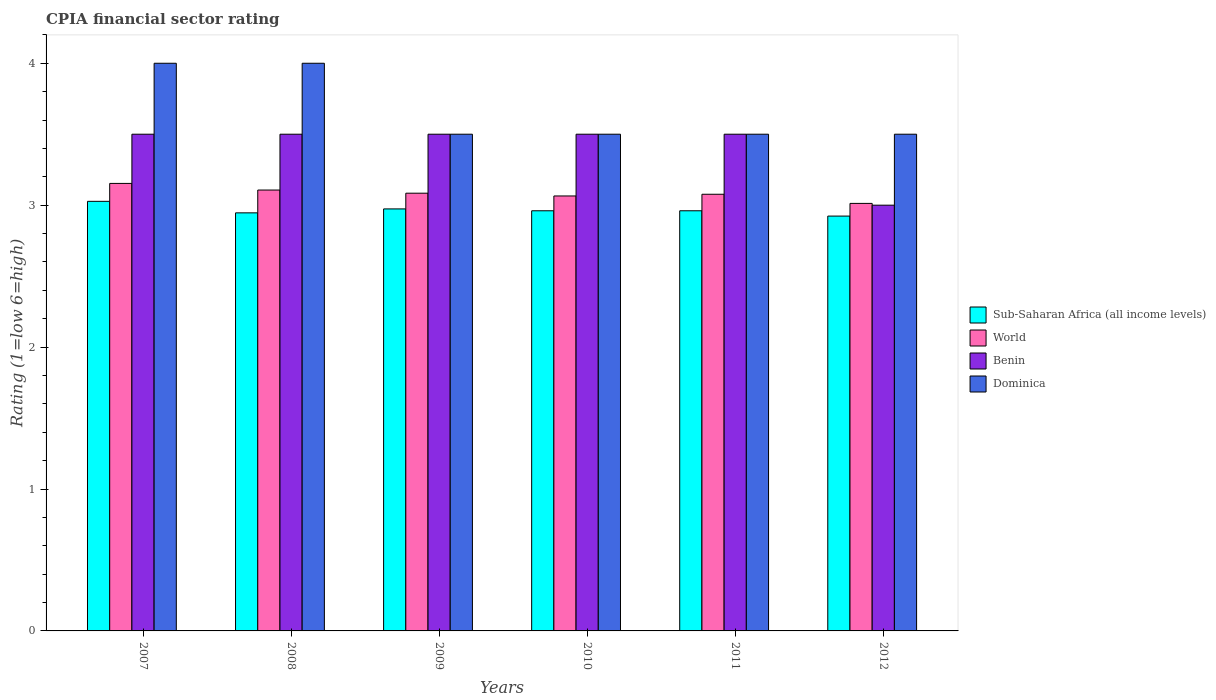How many groups of bars are there?
Make the answer very short. 6. How many bars are there on the 2nd tick from the left?
Offer a terse response. 4. In how many cases, is the number of bars for a given year not equal to the number of legend labels?
Your answer should be compact. 0. What is the CPIA rating in Dominica in 2010?
Give a very brief answer. 3.5. Across all years, what is the maximum CPIA rating in World?
Your response must be concise. 3.15. Across all years, what is the minimum CPIA rating in World?
Offer a very short reply. 3.01. What is the total CPIA rating in World in the graph?
Your answer should be compact. 18.5. What is the difference between the CPIA rating in Benin in 2009 and that in 2010?
Your answer should be compact. 0. What is the difference between the CPIA rating in Benin in 2010 and the CPIA rating in Sub-Saharan Africa (all income levels) in 2012?
Offer a very short reply. 0.58. What is the average CPIA rating in Sub-Saharan Africa (all income levels) per year?
Keep it short and to the point. 2.97. In the year 2011, what is the difference between the CPIA rating in Sub-Saharan Africa (all income levels) and CPIA rating in Dominica?
Ensure brevity in your answer.  -0.54. What is the ratio of the CPIA rating in Sub-Saharan Africa (all income levels) in 2009 to that in 2011?
Your response must be concise. 1. Is the difference between the CPIA rating in Sub-Saharan Africa (all income levels) in 2011 and 2012 greater than the difference between the CPIA rating in Dominica in 2011 and 2012?
Your answer should be compact. Yes. What is the difference between the highest and the second highest CPIA rating in World?
Your answer should be very brief. 0.05. What is the difference between the highest and the lowest CPIA rating in World?
Your response must be concise. 0.14. Is the sum of the CPIA rating in World in 2010 and 2012 greater than the maximum CPIA rating in Dominica across all years?
Offer a very short reply. Yes. Is it the case that in every year, the sum of the CPIA rating in Benin and CPIA rating in Sub-Saharan Africa (all income levels) is greater than the sum of CPIA rating in World and CPIA rating in Dominica?
Give a very brief answer. No. What does the 1st bar from the left in 2007 represents?
Your answer should be compact. Sub-Saharan Africa (all income levels). What does the 1st bar from the right in 2007 represents?
Offer a very short reply. Dominica. How many bars are there?
Your answer should be compact. 24. Are all the bars in the graph horizontal?
Give a very brief answer. No. How many years are there in the graph?
Provide a short and direct response. 6. Are the values on the major ticks of Y-axis written in scientific E-notation?
Offer a terse response. No. How are the legend labels stacked?
Your response must be concise. Vertical. What is the title of the graph?
Your answer should be compact. CPIA financial sector rating. Does "High income: OECD" appear as one of the legend labels in the graph?
Offer a very short reply. No. What is the label or title of the Y-axis?
Provide a short and direct response. Rating (1=low 6=high). What is the Rating (1=low 6=high) of Sub-Saharan Africa (all income levels) in 2007?
Your answer should be compact. 3.03. What is the Rating (1=low 6=high) in World in 2007?
Offer a very short reply. 3.15. What is the Rating (1=low 6=high) of Dominica in 2007?
Your answer should be compact. 4. What is the Rating (1=low 6=high) in Sub-Saharan Africa (all income levels) in 2008?
Provide a short and direct response. 2.95. What is the Rating (1=low 6=high) of World in 2008?
Give a very brief answer. 3.11. What is the Rating (1=low 6=high) in Benin in 2008?
Keep it short and to the point. 3.5. What is the Rating (1=low 6=high) of Dominica in 2008?
Your answer should be compact. 4. What is the Rating (1=low 6=high) in Sub-Saharan Africa (all income levels) in 2009?
Keep it short and to the point. 2.97. What is the Rating (1=low 6=high) in World in 2009?
Provide a succinct answer. 3.08. What is the Rating (1=low 6=high) of Sub-Saharan Africa (all income levels) in 2010?
Your answer should be compact. 2.96. What is the Rating (1=low 6=high) of World in 2010?
Offer a very short reply. 3.06. What is the Rating (1=low 6=high) in Sub-Saharan Africa (all income levels) in 2011?
Offer a very short reply. 2.96. What is the Rating (1=low 6=high) of World in 2011?
Your response must be concise. 3.08. What is the Rating (1=low 6=high) of Benin in 2011?
Keep it short and to the point. 3.5. What is the Rating (1=low 6=high) in Sub-Saharan Africa (all income levels) in 2012?
Offer a very short reply. 2.92. What is the Rating (1=low 6=high) in World in 2012?
Offer a very short reply. 3.01. Across all years, what is the maximum Rating (1=low 6=high) in Sub-Saharan Africa (all income levels)?
Make the answer very short. 3.03. Across all years, what is the maximum Rating (1=low 6=high) in World?
Make the answer very short. 3.15. Across all years, what is the maximum Rating (1=low 6=high) of Dominica?
Make the answer very short. 4. Across all years, what is the minimum Rating (1=low 6=high) of Sub-Saharan Africa (all income levels)?
Offer a terse response. 2.92. Across all years, what is the minimum Rating (1=low 6=high) in World?
Your answer should be very brief. 3.01. Across all years, what is the minimum Rating (1=low 6=high) of Benin?
Ensure brevity in your answer.  3. Across all years, what is the minimum Rating (1=low 6=high) of Dominica?
Keep it short and to the point. 3.5. What is the total Rating (1=low 6=high) in Sub-Saharan Africa (all income levels) in the graph?
Ensure brevity in your answer.  17.79. What is the total Rating (1=low 6=high) in World in the graph?
Offer a very short reply. 18.5. What is the difference between the Rating (1=low 6=high) in Sub-Saharan Africa (all income levels) in 2007 and that in 2008?
Ensure brevity in your answer.  0.08. What is the difference between the Rating (1=low 6=high) in World in 2007 and that in 2008?
Ensure brevity in your answer.  0.05. What is the difference between the Rating (1=low 6=high) in Benin in 2007 and that in 2008?
Ensure brevity in your answer.  0. What is the difference between the Rating (1=low 6=high) of Dominica in 2007 and that in 2008?
Make the answer very short. 0. What is the difference between the Rating (1=low 6=high) of Sub-Saharan Africa (all income levels) in 2007 and that in 2009?
Make the answer very short. 0.05. What is the difference between the Rating (1=low 6=high) of World in 2007 and that in 2009?
Your answer should be very brief. 0.07. What is the difference between the Rating (1=low 6=high) in Benin in 2007 and that in 2009?
Keep it short and to the point. 0. What is the difference between the Rating (1=low 6=high) in Dominica in 2007 and that in 2009?
Keep it short and to the point. 0.5. What is the difference between the Rating (1=low 6=high) in Sub-Saharan Africa (all income levels) in 2007 and that in 2010?
Make the answer very short. 0.07. What is the difference between the Rating (1=low 6=high) in World in 2007 and that in 2010?
Give a very brief answer. 0.09. What is the difference between the Rating (1=low 6=high) of Benin in 2007 and that in 2010?
Offer a terse response. 0. What is the difference between the Rating (1=low 6=high) of Dominica in 2007 and that in 2010?
Ensure brevity in your answer.  0.5. What is the difference between the Rating (1=low 6=high) of Sub-Saharan Africa (all income levels) in 2007 and that in 2011?
Give a very brief answer. 0.07. What is the difference between the Rating (1=low 6=high) of World in 2007 and that in 2011?
Provide a succinct answer. 0.08. What is the difference between the Rating (1=low 6=high) of Dominica in 2007 and that in 2011?
Offer a terse response. 0.5. What is the difference between the Rating (1=low 6=high) of Sub-Saharan Africa (all income levels) in 2007 and that in 2012?
Your answer should be very brief. 0.1. What is the difference between the Rating (1=low 6=high) of World in 2007 and that in 2012?
Ensure brevity in your answer.  0.14. What is the difference between the Rating (1=low 6=high) of Dominica in 2007 and that in 2012?
Your answer should be very brief. 0.5. What is the difference between the Rating (1=low 6=high) in Sub-Saharan Africa (all income levels) in 2008 and that in 2009?
Your answer should be compact. -0.03. What is the difference between the Rating (1=low 6=high) in World in 2008 and that in 2009?
Keep it short and to the point. 0.02. What is the difference between the Rating (1=low 6=high) in Benin in 2008 and that in 2009?
Your answer should be very brief. 0. What is the difference between the Rating (1=low 6=high) of Dominica in 2008 and that in 2009?
Ensure brevity in your answer.  0.5. What is the difference between the Rating (1=low 6=high) in Sub-Saharan Africa (all income levels) in 2008 and that in 2010?
Provide a succinct answer. -0.01. What is the difference between the Rating (1=low 6=high) of World in 2008 and that in 2010?
Give a very brief answer. 0.04. What is the difference between the Rating (1=low 6=high) of Sub-Saharan Africa (all income levels) in 2008 and that in 2011?
Give a very brief answer. -0.01. What is the difference between the Rating (1=low 6=high) of World in 2008 and that in 2011?
Provide a succinct answer. 0.03. What is the difference between the Rating (1=low 6=high) of Benin in 2008 and that in 2011?
Provide a succinct answer. 0. What is the difference between the Rating (1=low 6=high) in Dominica in 2008 and that in 2011?
Give a very brief answer. 0.5. What is the difference between the Rating (1=low 6=high) in Sub-Saharan Africa (all income levels) in 2008 and that in 2012?
Ensure brevity in your answer.  0.02. What is the difference between the Rating (1=low 6=high) of World in 2008 and that in 2012?
Keep it short and to the point. 0.09. What is the difference between the Rating (1=low 6=high) in Dominica in 2008 and that in 2012?
Offer a very short reply. 0.5. What is the difference between the Rating (1=low 6=high) of Sub-Saharan Africa (all income levels) in 2009 and that in 2010?
Offer a very short reply. 0.01. What is the difference between the Rating (1=low 6=high) in World in 2009 and that in 2010?
Provide a short and direct response. 0.02. What is the difference between the Rating (1=low 6=high) of Sub-Saharan Africa (all income levels) in 2009 and that in 2011?
Give a very brief answer. 0.01. What is the difference between the Rating (1=low 6=high) in World in 2009 and that in 2011?
Offer a terse response. 0.01. What is the difference between the Rating (1=low 6=high) of Benin in 2009 and that in 2011?
Your answer should be compact. 0. What is the difference between the Rating (1=low 6=high) in Sub-Saharan Africa (all income levels) in 2009 and that in 2012?
Your answer should be very brief. 0.05. What is the difference between the Rating (1=low 6=high) in World in 2009 and that in 2012?
Your response must be concise. 0.07. What is the difference between the Rating (1=low 6=high) of Dominica in 2009 and that in 2012?
Ensure brevity in your answer.  0. What is the difference between the Rating (1=low 6=high) of Sub-Saharan Africa (all income levels) in 2010 and that in 2011?
Keep it short and to the point. 0. What is the difference between the Rating (1=low 6=high) of World in 2010 and that in 2011?
Your response must be concise. -0.01. What is the difference between the Rating (1=low 6=high) in Benin in 2010 and that in 2011?
Offer a very short reply. 0. What is the difference between the Rating (1=low 6=high) of Sub-Saharan Africa (all income levels) in 2010 and that in 2012?
Your response must be concise. 0.04. What is the difference between the Rating (1=low 6=high) of World in 2010 and that in 2012?
Offer a terse response. 0.05. What is the difference between the Rating (1=low 6=high) in Sub-Saharan Africa (all income levels) in 2011 and that in 2012?
Keep it short and to the point. 0.04. What is the difference between the Rating (1=low 6=high) of World in 2011 and that in 2012?
Provide a short and direct response. 0.06. What is the difference between the Rating (1=low 6=high) of Benin in 2011 and that in 2012?
Provide a short and direct response. 0.5. What is the difference between the Rating (1=low 6=high) of Dominica in 2011 and that in 2012?
Give a very brief answer. 0. What is the difference between the Rating (1=low 6=high) of Sub-Saharan Africa (all income levels) in 2007 and the Rating (1=low 6=high) of World in 2008?
Your response must be concise. -0.08. What is the difference between the Rating (1=low 6=high) in Sub-Saharan Africa (all income levels) in 2007 and the Rating (1=low 6=high) in Benin in 2008?
Make the answer very short. -0.47. What is the difference between the Rating (1=low 6=high) of Sub-Saharan Africa (all income levels) in 2007 and the Rating (1=low 6=high) of Dominica in 2008?
Provide a succinct answer. -0.97. What is the difference between the Rating (1=low 6=high) in World in 2007 and the Rating (1=low 6=high) in Benin in 2008?
Make the answer very short. -0.35. What is the difference between the Rating (1=low 6=high) in World in 2007 and the Rating (1=low 6=high) in Dominica in 2008?
Keep it short and to the point. -0.85. What is the difference between the Rating (1=low 6=high) of Sub-Saharan Africa (all income levels) in 2007 and the Rating (1=low 6=high) of World in 2009?
Your response must be concise. -0.06. What is the difference between the Rating (1=low 6=high) in Sub-Saharan Africa (all income levels) in 2007 and the Rating (1=low 6=high) in Benin in 2009?
Your answer should be compact. -0.47. What is the difference between the Rating (1=low 6=high) in Sub-Saharan Africa (all income levels) in 2007 and the Rating (1=low 6=high) in Dominica in 2009?
Offer a very short reply. -0.47. What is the difference between the Rating (1=low 6=high) of World in 2007 and the Rating (1=low 6=high) of Benin in 2009?
Make the answer very short. -0.35. What is the difference between the Rating (1=low 6=high) of World in 2007 and the Rating (1=low 6=high) of Dominica in 2009?
Your response must be concise. -0.35. What is the difference between the Rating (1=low 6=high) in Sub-Saharan Africa (all income levels) in 2007 and the Rating (1=low 6=high) in World in 2010?
Provide a short and direct response. -0.04. What is the difference between the Rating (1=low 6=high) of Sub-Saharan Africa (all income levels) in 2007 and the Rating (1=low 6=high) of Benin in 2010?
Offer a terse response. -0.47. What is the difference between the Rating (1=low 6=high) of Sub-Saharan Africa (all income levels) in 2007 and the Rating (1=low 6=high) of Dominica in 2010?
Offer a very short reply. -0.47. What is the difference between the Rating (1=low 6=high) in World in 2007 and the Rating (1=low 6=high) in Benin in 2010?
Provide a succinct answer. -0.35. What is the difference between the Rating (1=low 6=high) of World in 2007 and the Rating (1=low 6=high) of Dominica in 2010?
Offer a very short reply. -0.35. What is the difference between the Rating (1=low 6=high) of Sub-Saharan Africa (all income levels) in 2007 and the Rating (1=low 6=high) of World in 2011?
Offer a terse response. -0.05. What is the difference between the Rating (1=low 6=high) of Sub-Saharan Africa (all income levels) in 2007 and the Rating (1=low 6=high) of Benin in 2011?
Give a very brief answer. -0.47. What is the difference between the Rating (1=low 6=high) in Sub-Saharan Africa (all income levels) in 2007 and the Rating (1=low 6=high) in Dominica in 2011?
Your answer should be very brief. -0.47. What is the difference between the Rating (1=low 6=high) of World in 2007 and the Rating (1=low 6=high) of Benin in 2011?
Provide a succinct answer. -0.35. What is the difference between the Rating (1=low 6=high) in World in 2007 and the Rating (1=low 6=high) in Dominica in 2011?
Provide a short and direct response. -0.35. What is the difference between the Rating (1=low 6=high) in Benin in 2007 and the Rating (1=low 6=high) in Dominica in 2011?
Provide a short and direct response. 0. What is the difference between the Rating (1=low 6=high) in Sub-Saharan Africa (all income levels) in 2007 and the Rating (1=low 6=high) in World in 2012?
Your answer should be very brief. 0.01. What is the difference between the Rating (1=low 6=high) of Sub-Saharan Africa (all income levels) in 2007 and the Rating (1=low 6=high) of Benin in 2012?
Your answer should be very brief. 0.03. What is the difference between the Rating (1=low 6=high) in Sub-Saharan Africa (all income levels) in 2007 and the Rating (1=low 6=high) in Dominica in 2012?
Your answer should be compact. -0.47. What is the difference between the Rating (1=low 6=high) of World in 2007 and the Rating (1=low 6=high) of Benin in 2012?
Ensure brevity in your answer.  0.15. What is the difference between the Rating (1=low 6=high) in World in 2007 and the Rating (1=low 6=high) in Dominica in 2012?
Offer a terse response. -0.35. What is the difference between the Rating (1=low 6=high) in Sub-Saharan Africa (all income levels) in 2008 and the Rating (1=low 6=high) in World in 2009?
Your response must be concise. -0.14. What is the difference between the Rating (1=low 6=high) in Sub-Saharan Africa (all income levels) in 2008 and the Rating (1=low 6=high) in Benin in 2009?
Offer a very short reply. -0.55. What is the difference between the Rating (1=low 6=high) in Sub-Saharan Africa (all income levels) in 2008 and the Rating (1=low 6=high) in Dominica in 2009?
Provide a short and direct response. -0.55. What is the difference between the Rating (1=low 6=high) of World in 2008 and the Rating (1=low 6=high) of Benin in 2009?
Your answer should be compact. -0.39. What is the difference between the Rating (1=low 6=high) of World in 2008 and the Rating (1=low 6=high) of Dominica in 2009?
Provide a succinct answer. -0.39. What is the difference between the Rating (1=low 6=high) in Benin in 2008 and the Rating (1=low 6=high) in Dominica in 2009?
Offer a terse response. 0. What is the difference between the Rating (1=low 6=high) in Sub-Saharan Africa (all income levels) in 2008 and the Rating (1=low 6=high) in World in 2010?
Provide a short and direct response. -0.12. What is the difference between the Rating (1=low 6=high) in Sub-Saharan Africa (all income levels) in 2008 and the Rating (1=low 6=high) in Benin in 2010?
Your response must be concise. -0.55. What is the difference between the Rating (1=low 6=high) of Sub-Saharan Africa (all income levels) in 2008 and the Rating (1=low 6=high) of Dominica in 2010?
Offer a very short reply. -0.55. What is the difference between the Rating (1=low 6=high) of World in 2008 and the Rating (1=low 6=high) of Benin in 2010?
Make the answer very short. -0.39. What is the difference between the Rating (1=low 6=high) of World in 2008 and the Rating (1=low 6=high) of Dominica in 2010?
Provide a short and direct response. -0.39. What is the difference between the Rating (1=low 6=high) in Benin in 2008 and the Rating (1=low 6=high) in Dominica in 2010?
Offer a terse response. 0. What is the difference between the Rating (1=low 6=high) of Sub-Saharan Africa (all income levels) in 2008 and the Rating (1=low 6=high) of World in 2011?
Make the answer very short. -0.13. What is the difference between the Rating (1=low 6=high) of Sub-Saharan Africa (all income levels) in 2008 and the Rating (1=low 6=high) of Benin in 2011?
Make the answer very short. -0.55. What is the difference between the Rating (1=low 6=high) of Sub-Saharan Africa (all income levels) in 2008 and the Rating (1=low 6=high) of Dominica in 2011?
Offer a very short reply. -0.55. What is the difference between the Rating (1=low 6=high) in World in 2008 and the Rating (1=low 6=high) in Benin in 2011?
Your response must be concise. -0.39. What is the difference between the Rating (1=low 6=high) of World in 2008 and the Rating (1=low 6=high) of Dominica in 2011?
Your response must be concise. -0.39. What is the difference between the Rating (1=low 6=high) of Sub-Saharan Africa (all income levels) in 2008 and the Rating (1=low 6=high) of World in 2012?
Your response must be concise. -0.07. What is the difference between the Rating (1=low 6=high) of Sub-Saharan Africa (all income levels) in 2008 and the Rating (1=low 6=high) of Benin in 2012?
Keep it short and to the point. -0.05. What is the difference between the Rating (1=low 6=high) in Sub-Saharan Africa (all income levels) in 2008 and the Rating (1=low 6=high) in Dominica in 2012?
Your response must be concise. -0.55. What is the difference between the Rating (1=low 6=high) in World in 2008 and the Rating (1=low 6=high) in Benin in 2012?
Make the answer very short. 0.11. What is the difference between the Rating (1=low 6=high) in World in 2008 and the Rating (1=low 6=high) in Dominica in 2012?
Your response must be concise. -0.39. What is the difference between the Rating (1=low 6=high) in Benin in 2008 and the Rating (1=low 6=high) in Dominica in 2012?
Keep it short and to the point. 0. What is the difference between the Rating (1=low 6=high) of Sub-Saharan Africa (all income levels) in 2009 and the Rating (1=low 6=high) of World in 2010?
Make the answer very short. -0.09. What is the difference between the Rating (1=low 6=high) of Sub-Saharan Africa (all income levels) in 2009 and the Rating (1=low 6=high) of Benin in 2010?
Give a very brief answer. -0.53. What is the difference between the Rating (1=low 6=high) in Sub-Saharan Africa (all income levels) in 2009 and the Rating (1=low 6=high) in Dominica in 2010?
Offer a terse response. -0.53. What is the difference between the Rating (1=low 6=high) of World in 2009 and the Rating (1=low 6=high) of Benin in 2010?
Offer a very short reply. -0.42. What is the difference between the Rating (1=low 6=high) of World in 2009 and the Rating (1=low 6=high) of Dominica in 2010?
Offer a terse response. -0.42. What is the difference between the Rating (1=low 6=high) in Benin in 2009 and the Rating (1=low 6=high) in Dominica in 2010?
Offer a terse response. 0. What is the difference between the Rating (1=low 6=high) in Sub-Saharan Africa (all income levels) in 2009 and the Rating (1=low 6=high) in World in 2011?
Offer a very short reply. -0.1. What is the difference between the Rating (1=low 6=high) of Sub-Saharan Africa (all income levels) in 2009 and the Rating (1=low 6=high) of Benin in 2011?
Give a very brief answer. -0.53. What is the difference between the Rating (1=low 6=high) of Sub-Saharan Africa (all income levels) in 2009 and the Rating (1=low 6=high) of Dominica in 2011?
Offer a very short reply. -0.53. What is the difference between the Rating (1=low 6=high) in World in 2009 and the Rating (1=low 6=high) in Benin in 2011?
Your response must be concise. -0.42. What is the difference between the Rating (1=low 6=high) in World in 2009 and the Rating (1=low 6=high) in Dominica in 2011?
Provide a short and direct response. -0.42. What is the difference between the Rating (1=low 6=high) in Sub-Saharan Africa (all income levels) in 2009 and the Rating (1=low 6=high) in World in 2012?
Your response must be concise. -0.04. What is the difference between the Rating (1=low 6=high) in Sub-Saharan Africa (all income levels) in 2009 and the Rating (1=low 6=high) in Benin in 2012?
Offer a very short reply. -0.03. What is the difference between the Rating (1=low 6=high) in Sub-Saharan Africa (all income levels) in 2009 and the Rating (1=low 6=high) in Dominica in 2012?
Your answer should be compact. -0.53. What is the difference between the Rating (1=low 6=high) of World in 2009 and the Rating (1=low 6=high) of Benin in 2012?
Your response must be concise. 0.08. What is the difference between the Rating (1=low 6=high) in World in 2009 and the Rating (1=low 6=high) in Dominica in 2012?
Ensure brevity in your answer.  -0.42. What is the difference between the Rating (1=low 6=high) of Benin in 2009 and the Rating (1=low 6=high) of Dominica in 2012?
Provide a short and direct response. 0. What is the difference between the Rating (1=low 6=high) of Sub-Saharan Africa (all income levels) in 2010 and the Rating (1=low 6=high) of World in 2011?
Your response must be concise. -0.12. What is the difference between the Rating (1=low 6=high) in Sub-Saharan Africa (all income levels) in 2010 and the Rating (1=low 6=high) in Benin in 2011?
Provide a short and direct response. -0.54. What is the difference between the Rating (1=low 6=high) in Sub-Saharan Africa (all income levels) in 2010 and the Rating (1=low 6=high) in Dominica in 2011?
Give a very brief answer. -0.54. What is the difference between the Rating (1=low 6=high) of World in 2010 and the Rating (1=low 6=high) of Benin in 2011?
Provide a short and direct response. -0.44. What is the difference between the Rating (1=low 6=high) of World in 2010 and the Rating (1=low 6=high) of Dominica in 2011?
Offer a very short reply. -0.44. What is the difference between the Rating (1=low 6=high) in Benin in 2010 and the Rating (1=low 6=high) in Dominica in 2011?
Provide a succinct answer. 0. What is the difference between the Rating (1=low 6=high) in Sub-Saharan Africa (all income levels) in 2010 and the Rating (1=low 6=high) in World in 2012?
Offer a terse response. -0.05. What is the difference between the Rating (1=low 6=high) of Sub-Saharan Africa (all income levels) in 2010 and the Rating (1=low 6=high) of Benin in 2012?
Offer a very short reply. -0.04. What is the difference between the Rating (1=low 6=high) of Sub-Saharan Africa (all income levels) in 2010 and the Rating (1=low 6=high) of Dominica in 2012?
Provide a short and direct response. -0.54. What is the difference between the Rating (1=low 6=high) in World in 2010 and the Rating (1=low 6=high) in Benin in 2012?
Ensure brevity in your answer.  0.06. What is the difference between the Rating (1=low 6=high) in World in 2010 and the Rating (1=low 6=high) in Dominica in 2012?
Your answer should be compact. -0.44. What is the difference between the Rating (1=low 6=high) of Benin in 2010 and the Rating (1=low 6=high) of Dominica in 2012?
Make the answer very short. 0. What is the difference between the Rating (1=low 6=high) in Sub-Saharan Africa (all income levels) in 2011 and the Rating (1=low 6=high) in World in 2012?
Provide a short and direct response. -0.05. What is the difference between the Rating (1=low 6=high) of Sub-Saharan Africa (all income levels) in 2011 and the Rating (1=low 6=high) of Benin in 2012?
Ensure brevity in your answer.  -0.04. What is the difference between the Rating (1=low 6=high) of Sub-Saharan Africa (all income levels) in 2011 and the Rating (1=low 6=high) of Dominica in 2012?
Your response must be concise. -0.54. What is the difference between the Rating (1=low 6=high) in World in 2011 and the Rating (1=low 6=high) in Benin in 2012?
Ensure brevity in your answer.  0.08. What is the difference between the Rating (1=low 6=high) in World in 2011 and the Rating (1=low 6=high) in Dominica in 2012?
Provide a succinct answer. -0.42. What is the average Rating (1=low 6=high) of Sub-Saharan Africa (all income levels) per year?
Give a very brief answer. 2.97. What is the average Rating (1=low 6=high) in World per year?
Give a very brief answer. 3.08. What is the average Rating (1=low 6=high) of Benin per year?
Give a very brief answer. 3.42. What is the average Rating (1=low 6=high) in Dominica per year?
Give a very brief answer. 3.67. In the year 2007, what is the difference between the Rating (1=low 6=high) in Sub-Saharan Africa (all income levels) and Rating (1=low 6=high) in World?
Offer a very short reply. -0.13. In the year 2007, what is the difference between the Rating (1=low 6=high) in Sub-Saharan Africa (all income levels) and Rating (1=low 6=high) in Benin?
Offer a terse response. -0.47. In the year 2007, what is the difference between the Rating (1=low 6=high) of Sub-Saharan Africa (all income levels) and Rating (1=low 6=high) of Dominica?
Give a very brief answer. -0.97. In the year 2007, what is the difference between the Rating (1=low 6=high) in World and Rating (1=low 6=high) in Benin?
Your answer should be compact. -0.35. In the year 2007, what is the difference between the Rating (1=low 6=high) of World and Rating (1=low 6=high) of Dominica?
Make the answer very short. -0.85. In the year 2007, what is the difference between the Rating (1=low 6=high) in Benin and Rating (1=low 6=high) in Dominica?
Offer a very short reply. -0.5. In the year 2008, what is the difference between the Rating (1=low 6=high) in Sub-Saharan Africa (all income levels) and Rating (1=low 6=high) in World?
Make the answer very short. -0.16. In the year 2008, what is the difference between the Rating (1=low 6=high) of Sub-Saharan Africa (all income levels) and Rating (1=low 6=high) of Benin?
Offer a terse response. -0.55. In the year 2008, what is the difference between the Rating (1=low 6=high) in Sub-Saharan Africa (all income levels) and Rating (1=low 6=high) in Dominica?
Offer a very short reply. -1.05. In the year 2008, what is the difference between the Rating (1=low 6=high) of World and Rating (1=low 6=high) of Benin?
Offer a very short reply. -0.39. In the year 2008, what is the difference between the Rating (1=low 6=high) of World and Rating (1=low 6=high) of Dominica?
Offer a very short reply. -0.89. In the year 2009, what is the difference between the Rating (1=low 6=high) of Sub-Saharan Africa (all income levels) and Rating (1=low 6=high) of World?
Your answer should be very brief. -0.11. In the year 2009, what is the difference between the Rating (1=low 6=high) in Sub-Saharan Africa (all income levels) and Rating (1=low 6=high) in Benin?
Your response must be concise. -0.53. In the year 2009, what is the difference between the Rating (1=low 6=high) in Sub-Saharan Africa (all income levels) and Rating (1=low 6=high) in Dominica?
Give a very brief answer. -0.53. In the year 2009, what is the difference between the Rating (1=low 6=high) of World and Rating (1=low 6=high) of Benin?
Provide a short and direct response. -0.42. In the year 2009, what is the difference between the Rating (1=low 6=high) in World and Rating (1=low 6=high) in Dominica?
Your answer should be very brief. -0.42. In the year 2009, what is the difference between the Rating (1=low 6=high) of Benin and Rating (1=low 6=high) of Dominica?
Your response must be concise. 0. In the year 2010, what is the difference between the Rating (1=low 6=high) in Sub-Saharan Africa (all income levels) and Rating (1=low 6=high) in World?
Your answer should be compact. -0.1. In the year 2010, what is the difference between the Rating (1=low 6=high) of Sub-Saharan Africa (all income levels) and Rating (1=low 6=high) of Benin?
Keep it short and to the point. -0.54. In the year 2010, what is the difference between the Rating (1=low 6=high) in Sub-Saharan Africa (all income levels) and Rating (1=low 6=high) in Dominica?
Provide a short and direct response. -0.54. In the year 2010, what is the difference between the Rating (1=low 6=high) in World and Rating (1=low 6=high) in Benin?
Give a very brief answer. -0.44. In the year 2010, what is the difference between the Rating (1=low 6=high) of World and Rating (1=low 6=high) of Dominica?
Give a very brief answer. -0.44. In the year 2011, what is the difference between the Rating (1=low 6=high) in Sub-Saharan Africa (all income levels) and Rating (1=low 6=high) in World?
Ensure brevity in your answer.  -0.12. In the year 2011, what is the difference between the Rating (1=low 6=high) of Sub-Saharan Africa (all income levels) and Rating (1=low 6=high) of Benin?
Make the answer very short. -0.54. In the year 2011, what is the difference between the Rating (1=low 6=high) of Sub-Saharan Africa (all income levels) and Rating (1=low 6=high) of Dominica?
Offer a terse response. -0.54. In the year 2011, what is the difference between the Rating (1=low 6=high) of World and Rating (1=low 6=high) of Benin?
Give a very brief answer. -0.42. In the year 2011, what is the difference between the Rating (1=low 6=high) of World and Rating (1=low 6=high) of Dominica?
Your answer should be very brief. -0.42. In the year 2012, what is the difference between the Rating (1=low 6=high) in Sub-Saharan Africa (all income levels) and Rating (1=low 6=high) in World?
Your response must be concise. -0.09. In the year 2012, what is the difference between the Rating (1=low 6=high) of Sub-Saharan Africa (all income levels) and Rating (1=low 6=high) of Benin?
Give a very brief answer. -0.08. In the year 2012, what is the difference between the Rating (1=low 6=high) of Sub-Saharan Africa (all income levels) and Rating (1=low 6=high) of Dominica?
Offer a very short reply. -0.58. In the year 2012, what is the difference between the Rating (1=low 6=high) of World and Rating (1=low 6=high) of Benin?
Your answer should be compact. 0.01. In the year 2012, what is the difference between the Rating (1=low 6=high) in World and Rating (1=low 6=high) in Dominica?
Your answer should be very brief. -0.49. What is the ratio of the Rating (1=low 6=high) of Sub-Saharan Africa (all income levels) in 2007 to that in 2008?
Offer a terse response. 1.03. What is the ratio of the Rating (1=low 6=high) of World in 2007 to that in 2008?
Your answer should be very brief. 1.01. What is the ratio of the Rating (1=low 6=high) in Sub-Saharan Africa (all income levels) in 2007 to that in 2009?
Give a very brief answer. 1.02. What is the ratio of the Rating (1=low 6=high) of World in 2007 to that in 2009?
Give a very brief answer. 1.02. What is the ratio of the Rating (1=low 6=high) in Benin in 2007 to that in 2009?
Your answer should be compact. 1. What is the ratio of the Rating (1=low 6=high) of Dominica in 2007 to that in 2009?
Make the answer very short. 1.14. What is the ratio of the Rating (1=low 6=high) in Sub-Saharan Africa (all income levels) in 2007 to that in 2010?
Ensure brevity in your answer.  1.02. What is the ratio of the Rating (1=low 6=high) of World in 2007 to that in 2010?
Ensure brevity in your answer.  1.03. What is the ratio of the Rating (1=low 6=high) in Benin in 2007 to that in 2010?
Your response must be concise. 1. What is the ratio of the Rating (1=low 6=high) of Sub-Saharan Africa (all income levels) in 2007 to that in 2011?
Your answer should be compact. 1.02. What is the ratio of the Rating (1=low 6=high) of World in 2007 to that in 2011?
Your answer should be very brief. 1.02. What is the ratio of the Rating (1=low 6=high) in Benin in 2007 to that in 2011?
Your answer should be compact. 1. What is the ratio of the Rating (1=low 6=high) of Sub-Saharan Africa (all income levels) in 2007 to that in 2012?
Offer a very short reply. 1.04. What is the ratio of the Rating (1=low 6=high) of World in 2007 to that in 2012?
Keep it short and to the point. 1.05. What is the ratio of the Rating (1=low 6=high) in World in 2008 to that in 2009?
Offer a terse response. 1.01. What is the ratio of the Rating (1=low 6=high) of Benin in 2008 to that in 2009?
Your response must be concise. 1. What is the ratio of the Rating (1=low 6=high) in Dominica in 2008 to that in 2009?
Keep it short and to the point. 1.14. What is the ratio of the Rating (1=low 6=high) in World in 2008 to that in 2010?
Make the answer very short. 1.01. What is the ratio of the Rating (1=low 6=high) of Benin in 2008 to that in 2010?
Offer a very short reply. 1. What is the ratio of the Rating (1=low 6=high) of Dominica in 2008 to that in 2010?
Your answer should be very brief. 1.14. What is the ratio of the Rating (1=low 6=high) of Sub-Saharan Africa (all income levels) in 2008 to that in 2011?
Keep it short and to the point. 1. What is the ratio of the Rating (1=low 6=high) of World in 2008 to that in 2011?
Your answer should be very brief. 1.01. What is the ratio of the Rating (1=low 6=high) in Dominica in 2008 to that in 2011?
Your answer should be compact. 1.14. What is the ratio of the Rating (1=low 6=high) in World in 2008 to that in 2012?
Make the answer very short. 1.03. What is the ratio of the Rating (1=low 6=high) in Dominica in 2008 to that in 2012?
Ensure brevity in your answer.  1.14. What is the ratio of the Rating (1=low 6=high) of World in 2009 to that in 2010?
Your response must be concise. 1.01. What is the ratio of the Rating (1=low 6=high) of Sub-Saharan Africa (all income levels) in 2009 to that in 2011?
Provide a succinct answer. 1. What is the ratio of the Rating (1=low 6=high) in Sub-Saharan Africa (all income levels) in 2009 to that in 2012?
Your response must be concise. 1.02. What is the ratio of the Rating (1=low 6=high) of World in 2009 to that in 2012?
Ensure brevity in your answer.  1.02. What is the ratio of the Rating (1=low 6=high) in Benin in 2009 to that in 2012?
Your answer should be very brief. 1.17. What is the ratio of the Rating (1=low 6=high) in Dominica in 2009 to that in 2012?
Your answer should be compact. 1. What is the ratio of the Rating (1=low 6=high) of Sub-Saharan Africa (all income levels) in 2010 to that in 2011?
Provide a short and direct response. 1. What is the ratio of the Rating (1=low 6=high) of Dominica in 2010 to that in 2011?
Your response must be concise. 1. What is the ratio of the Rating (1=low 6=high) of Sub-Saharan Africa (all income levels) in 2010 to that in 2012?
Your answer should be compact. 1.01. What is the ratio of the Rating (1=low 6=high) of World in 2010 to that in 2012?
Make the answer very short. 1.02. What is the ratio of the Rating (1=low 6=high) in Benin in 2010 to that in 2012?
Offer a very short reply. 1.17. What is the ratio of the Rating (1=low 6=high) of Sub-Saharan Africa (all income levels) in 2011 to that in 2012?
Your answer should be compact. 1.01. What is the ratio of the Rating (1=low 6=high) in World in 2011 to that in 2012?
Offer a very short reply. 1.02. What is the difference between the highest and the second highest Rating (1=low 6=high) of Sub-Saharan Africa (all income levels)?
Ensure brevity in your answer.  0.05. What is the difference between the highest and the second highest Rating (1=low 6=high) of World?
Give a very brief answer. 0.05. What is the difference between the highest and the second highest Rating (1=low 6=high) in Benin?
Offer a terse response. 0. What is the difference between the highest and the lowest Rating (1=low 6=high) of Sub-Saharan Africa (all income levels)?
Your response must be concise. 0.1. What is the difference between the highest and the lowest Rating (1=low 6=high) of World?
Give a very brief answer. 0.14. What is the difference between the highest and the lowest Rating (1=low 6=high) of Dominica?
Ensure brevity in your answer.  0.5. 